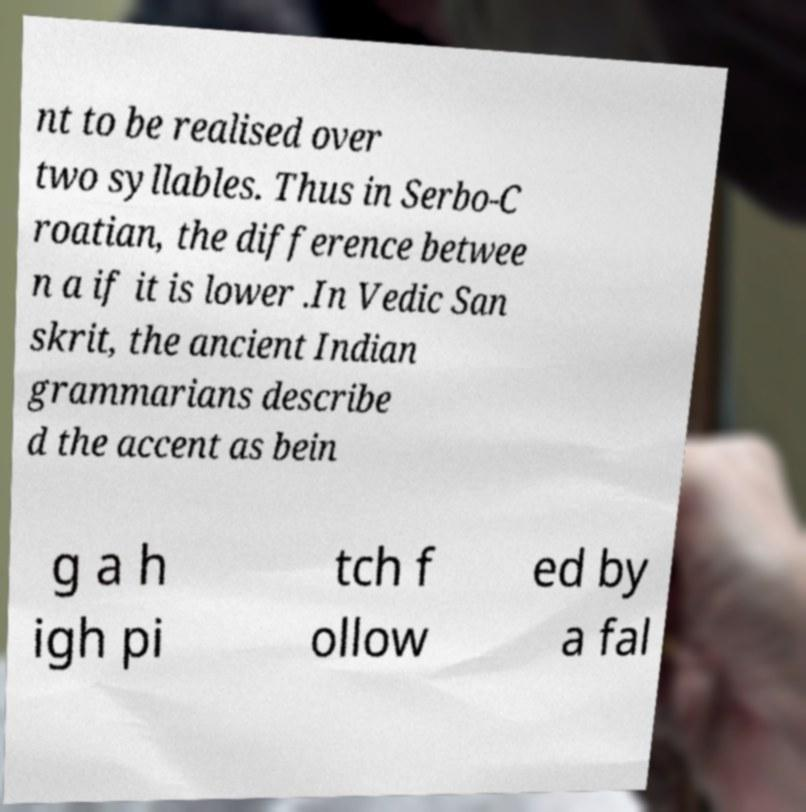Could you assist in decoding the text presented in this image and type it out clearly? nt to be realised over two syllables. Thus in Serbo-C roatian, the difference betwee n a if it is lower .In Vedic San skrit, the ancient Indian grammarians describe d the accent as bein g a h igh pi tch f ollow ed by a fal 